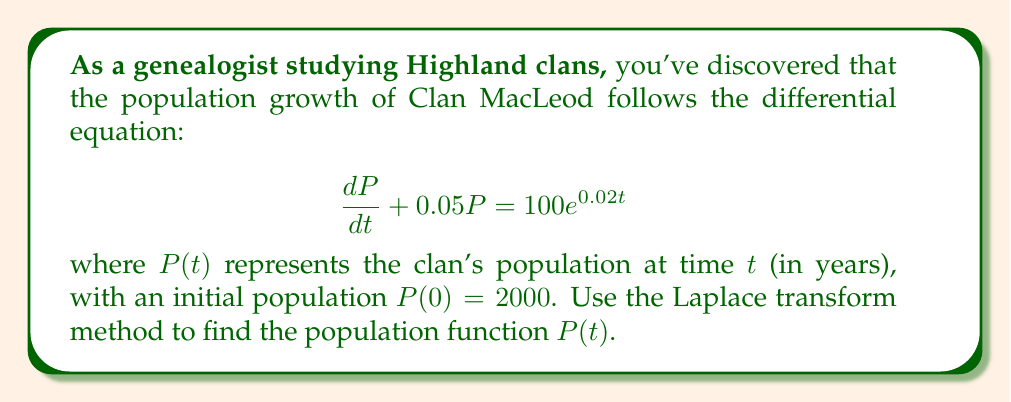Help me with this question. 1) Take the Laplace transform of both sides of the equation:
   $$\mathcal{L}\{\frac{dP}{dt} + 0.05P\} = \mathcal{L}\{100e^{0.02t}\}$$

2) Using Laplace transform properties:
   $$sP(s) - P(0) + 0.05P(s) = \frac{100}{s-0.02}$$

3) Substitute $P(0) = 2000$:
   $$sP(s) - 2000 + 0.05P(s) = \frac{100}{s-0.02}$$

4) Combine like terms:
   $$(s + 0.05)P(s) = 2000 + \frac{100}{s-0.02}$$

5) Solve for $P(s)$:
   $$P(s) = \frac{2000}{s + 0.05} + \frac{100}{(s + 0.05)(s - 0.02)}$$

6) Perform partial fraction decomposition:
   $$P(s) = \frac{2000}{s + 0.05} + \frac{A}{s + 0.05} + \frac{B}{s - 0.02}$$
   
   where $A = \frac{100}{-0.07} \approx -1428.57$ and $B = \frac{100}{0.07} \approx 1428.57$

7) Take the inverse Laplace transform:
   $$P(t) = \mathcal{L}^{-1}\{\frac{2000}{s + 0.05}\} + \mathcal{L}^{-1}\{\frac{A}{s + 0.05}\} + \mathcal{L}^{-1}\{\frac{B}{s - 0.02}\}$$

8) Simplify:
   $$P(t) = 2000e^{-0.05t} - 1428.57e^{-0.05t} + 1428.57e^{0.02t}$$

9) Combine like terms:
   $$P(t) = 571.43e^{-0.05t} + 1428.57e^{0.02t}$$
Answer: $P(t) = 571.43e^{-0.05t} + 1428.57e^{0.02t}$ 